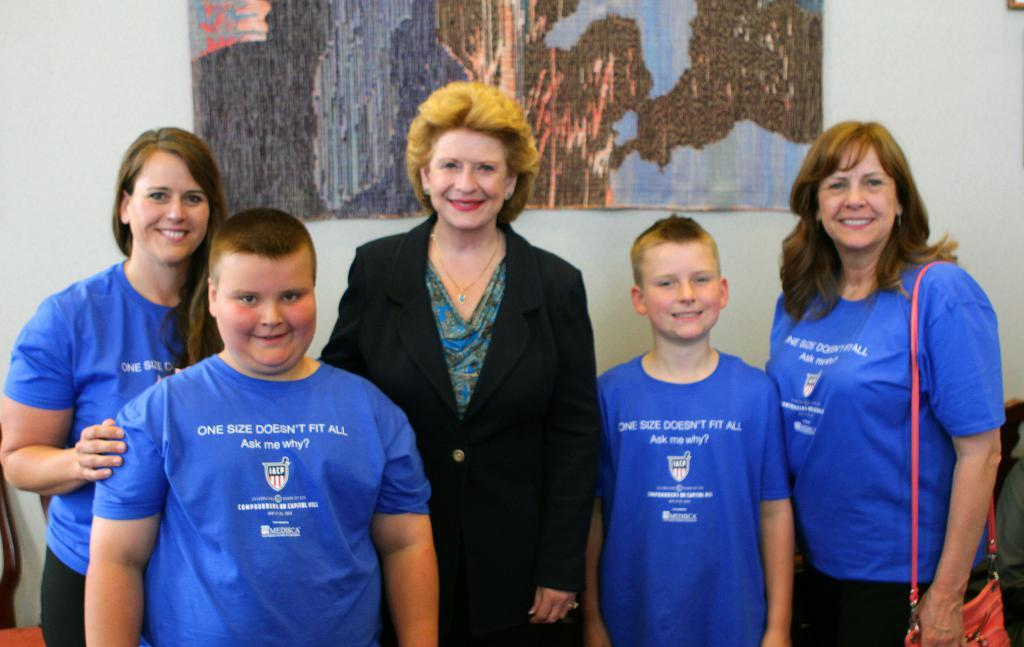<image>
Describe the image concisely. Children are wearing blue shirts that say one size doesn't fit all 